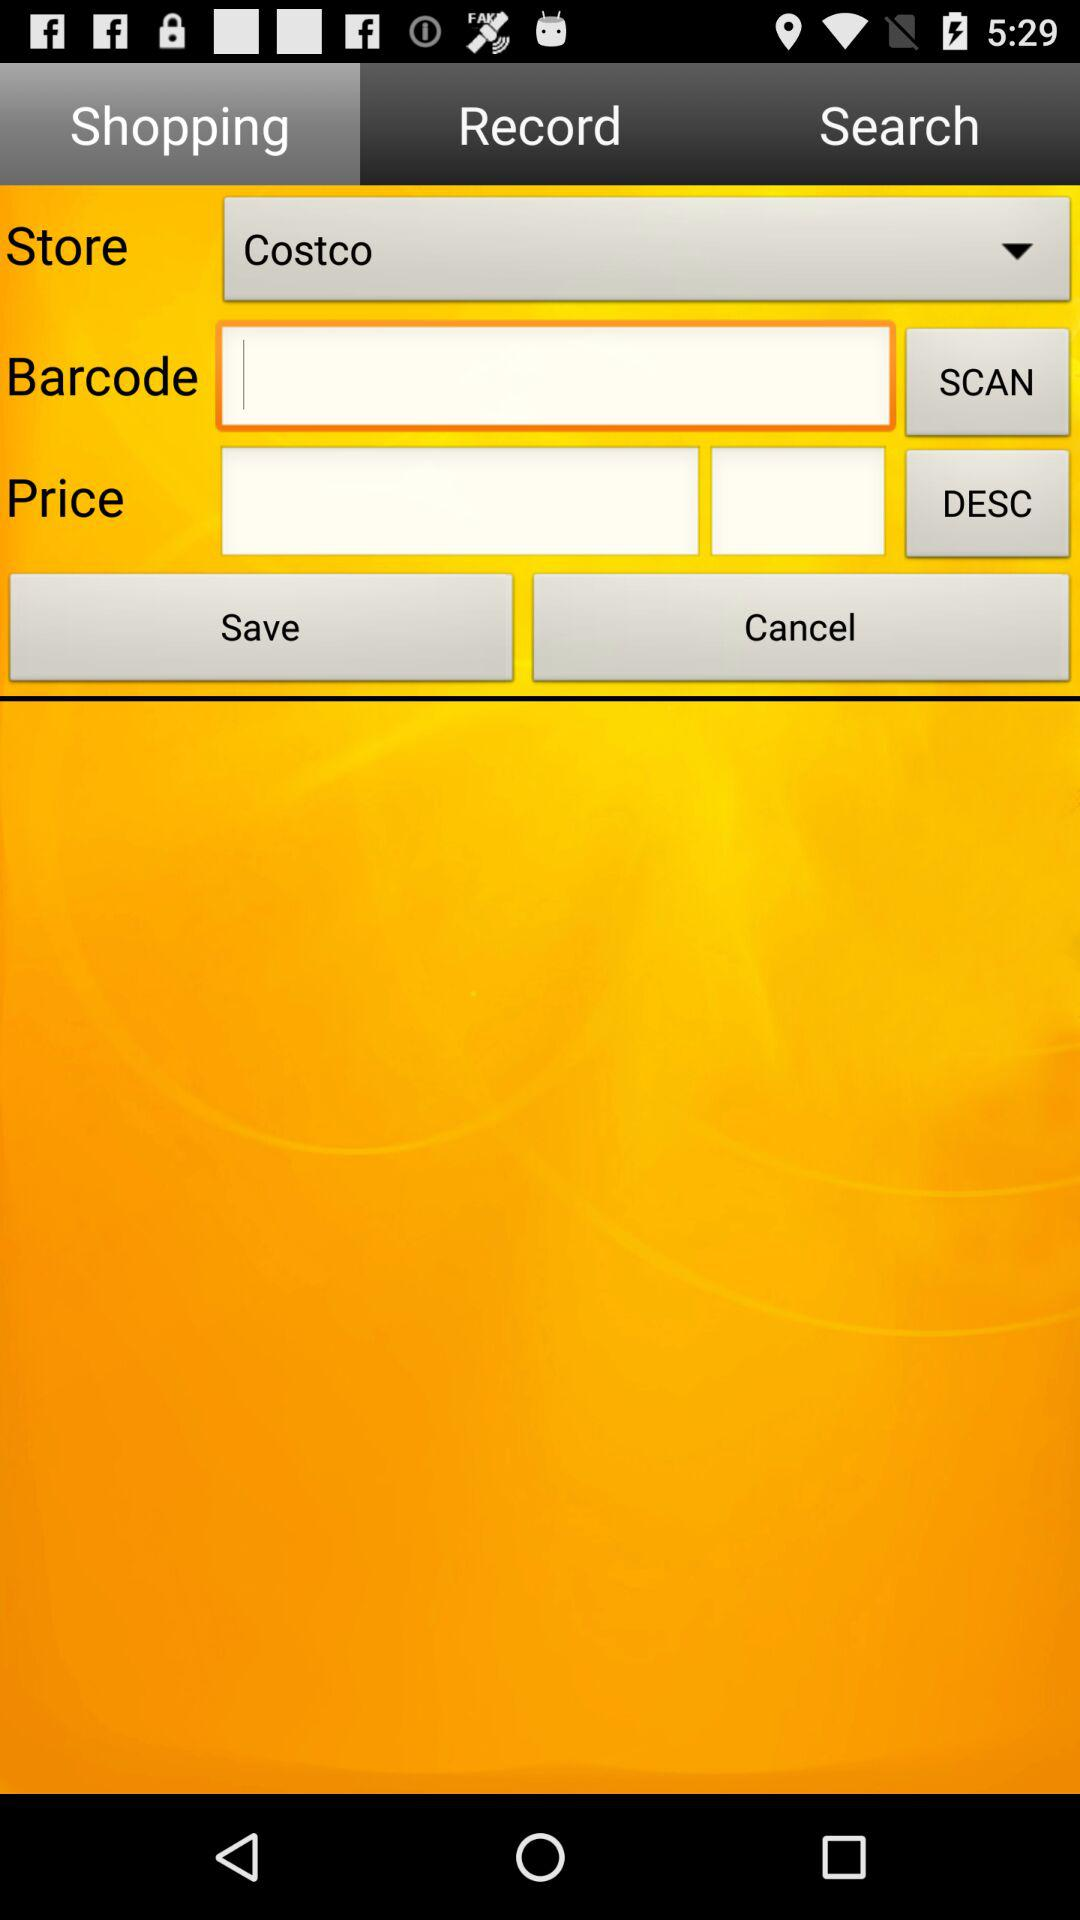Which is the selected tab? The selected tab is "Shopping". 